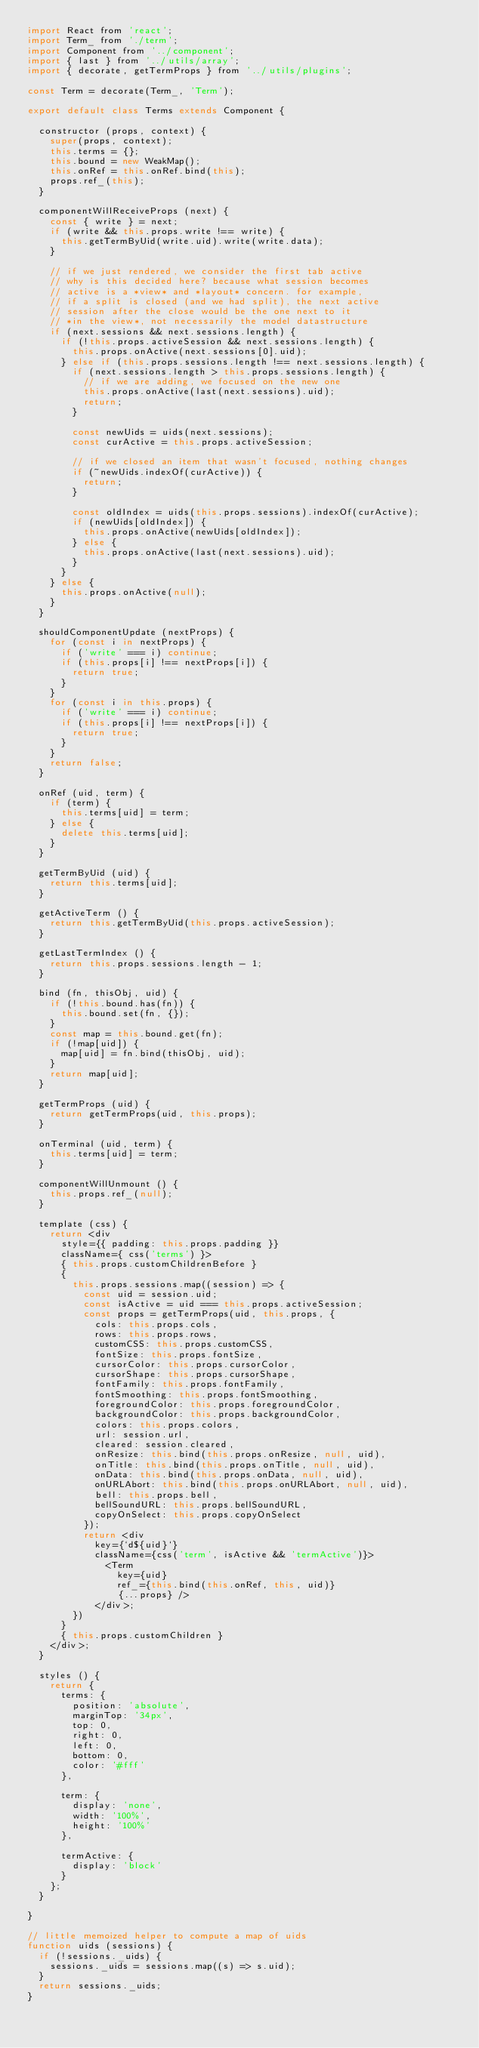<code> <loc_0><loc_0><loc_500><loc_500><_JavaScript_>import React from 'react';
import Term_ from './term';
import Component from '../component';
import { last } from '../utils/array';
import { decorate, getTermProps } from '../utils/plugins';

const Term = decorate(Term_, 'Term');

export default class Terms extends Component {

  constructor (props, context) {
    super(props, context);
    this.terms = {};
    this.bound = new WeakMap();
    this.onRef = this.onRef.bind(this);
    props.ref_(this);
  }

  componentWillReceiveProps (next) {
    const { write } = next;
    if (write && this.props.write !== write) {
      this.getTermByUid(write.uid).write(write.data);
    }

    // if we just rendered, we consider the first tab active
    // why is this decided here? because what session becomes
    // active is a *view* and *layout* concern. for example,
    // if a split is closed (and we had split), the next active
    // session after the close would be the one next to it
    // *in the view*, not necessarily the model datastructure
    if (next.sessions && next.sessions.length) {
      if (!this.props.activeSession && next.sessions.length) {
        this.props.onActive(next.sessions[0].uid);
      } else if (this.props.sessions.length !== next.sessions.length) {
        if (next.sessions.length > this.props.sessions.length) {
          // if we are adding, we focused on the new one
          this.props.onActive(last(next.sessions).uid);
          return;
        }

        const newUids = uids(next.sessions);
        const curActive = this.props.activeSession;

        // if we closed an item that wasn't focused, nothing changes
        if (~newUids.indexOf(curActive)) {
          return;
        }

        const oldIndex = uids(this.props.sessions).indexOf(curActive);
        if (newUids[oldIndex]) {
          this.props.onActive(newUids[oldIndex]);
        } else {
          this.props.onActive(last(next.sessions).uid);
        }
      }
    } else {
      this.props.onActive(null);
    }
  }

  shouldComponentUpdate (nextProps) {
    for (const i in nextProps) {
      if ('write' === i) continue;
      if (this.props[i] !== nextProps[i]) {
        return true;
      }
    }
    for (const i in this.props) {
      if ('write' === i) continue;
      if (this.props[i] !== nextProps[i]) {
        return true;
      }
    }
    return false;
  }

  onRef (uid, term) {
    if (term) {
      this.terms[uid] = term;
    } else {
      delete this.terms[uid];
    }
  }

  getTermByUid (uid) {
    return this.terms[uid];
  }

  getActiveTerm () {
    return this.getTermByUid(this.props.activeSession);
  }

  getLastTermIndex () {
    return this.props.sessions.length - 1;
  }

  bind (fn, thisObj, uid) {
    if (!this.bound.has(fn)) {
      this.bound.set(fn, {});
    }
    const map = this.bound.get(fn);
    if (!map[uid]) {
      map[uid] = fn.bind(thisObj, uid);
    }
    return map[uid];
  }

  getTermProps (uid) {
    return getTermProps(uid, this.props);
  }

  onTerminal (uid, term) {
    this.terms[uid] = term;
  }

  componentWillUnmount () {
    this.props.ref_(null);
  }

  template (css) {
    return <div
      style={{ padding: this.props.padding }}
      className={ css('terms') }>
      { this.props.customChildrenBefore }
      {
        this.props.sessions.map((session) => {
          const uid = session.uid;
          const isActive = uid === this.props.activeSession;
          const props = getTermProps(uid, this.props, {
            cols: this.props.cols,
            rows: this.props.rows,
            customCSS: this.props.customCSS,
            fontSize: this.props.fontSize,
            cursorColor: this.props.cursorColor,
            cursorShape: this.props.cursorShape,
            fontFamily: this.props.fontFamily,
            fontSmoothing: this.props.fontSmoothing,
            foregroundColor: this.props.foregroundColor,
            backgroundColor: this.props.backgroundColor,
            colors: this.props.colors,
            url: session.url,
            cleared: session.cleared,
            onResize: this.bind(this.props.onResize, null, uid),
            onTitle: this.bind(this.props.onTitle, null, uid),
            onData: this.bind(this.props.onData, null, uid),
            onURLAbort: this.bind(this.props.onURLAbort, null, uid),
            bell: this.props.bell,
            bellSoundURL: this.props.bellSoundURL,
            copyOnSelect: this.props.copyOnSelect
          });
          return <div
            key={`d${uid}`}
            className={css('term', isActive && 'termActive')}>
              <Term
                key={uid}
                ref_={this.bind(this.onRef, this, uid)}
                {...props} />
            </div>;
        })
      }
      { this.props.customChildren }
    </div>;
  }

  styles () {
    return {
      terms: {
        position: 'absolute',
        marginTop: '34px',
        top: 0,
        right: 0,
        left: 0,
        bottom: 0,
        color: '#fff'
      },

      term: {
        display: 'none',
        width: '100%',
        height: '100%'
      },

      termActive: {
        display: 'block'
      }
    };
  }

}

// little memoized helper to compute a map of uids
function uids (sessions) {
  if (!sessions._uids) {
    sessions._uids = sessions.map((s) => s.uid);
  }
  return sessions._uids;
}
</code> 